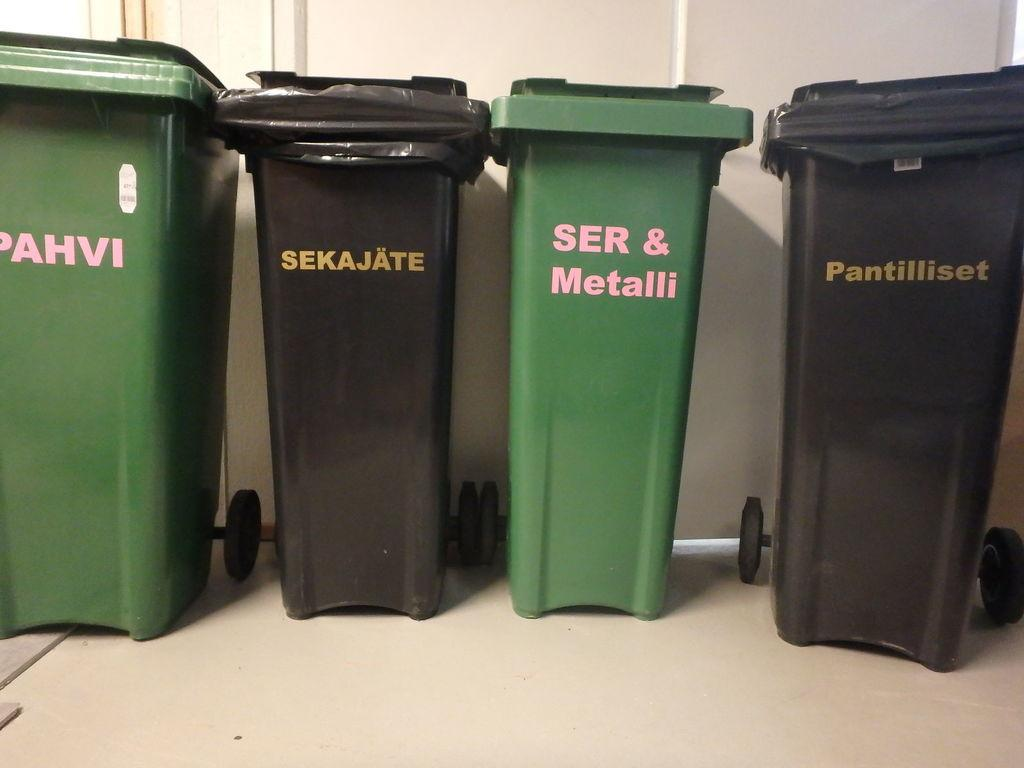<image>
Write a terse but informative summary of the picture. Pahvi, Sekajate, Ser & Metalli, and Pantilliset trash cans on the floor. 